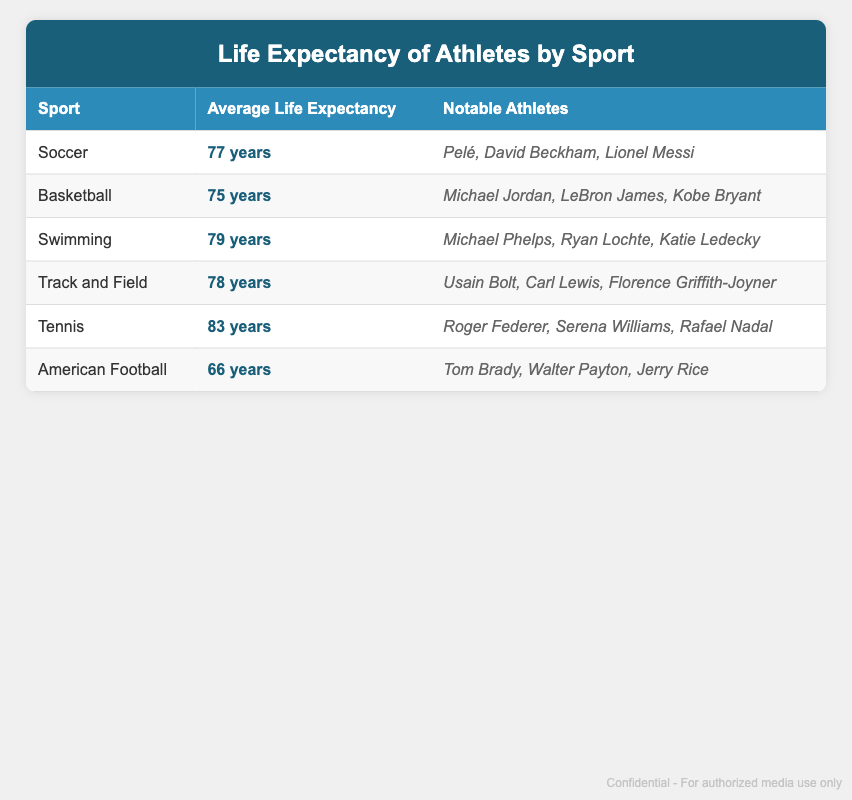What is the average life expectancy of soccer players? The table shows that the average life expectancy of soccer players is listed under the "Average Life Expectancy" column next to the "Soccer" row, which indicates 77 years.
Answer: 77 years Which sport has the highest average life expectancy? By reviewing the table, tennis is listed as having the highest average life expectancy at 83 years, higher than all other sports listed.
Answer: Tennis How many years longer do swimmers live on average compared to basketball players? The average life expectancy for swimmers is 79 years while for basketball players it is 75 years. Subtracting these values, we find 79 - 75 = 4 years.
Answer: 4 years Is it true that American football players have a longer life expectancy than basketball players? Based on the table, American football players have an average life expectancy of 66 years, while basketball players have an average life expectancy of 75 years. Therefore, it is false that football players live longer.
Answer: No What is the average life expectancy across all sports listed in the table? To find the average life expectancy, we sum all the values: 77 + 75 + 79 + 78 + 83 + 66 = 458. Then dividing by the number of sports (6) gives us 458 / 6 = 76.33, which rounds to approximately 76.3 years.
Answer: 76.3 years If we compare track and field athletes with swimmers, how much longer do swimmers live on average? Track and field athletes have an average life expectancy of 78 years. Subtracting the track and field average from the swimming average, 79 - 78 = 1 year, shows that swimmers live 1 year longer.
Answer: 1 year Name a notable athlete from soccer. The notable athletes listed under the soccer category include Pelé, David Beckham, and Lionel Messi, any of which can be cited as examples.
Answer: Pelé Which sport has the lowest average life expectancy listed? A review of the table indicates that American football has the lowest average life expectancy at 66 years, which is lower than the other sports listed.
Answer: American Football 